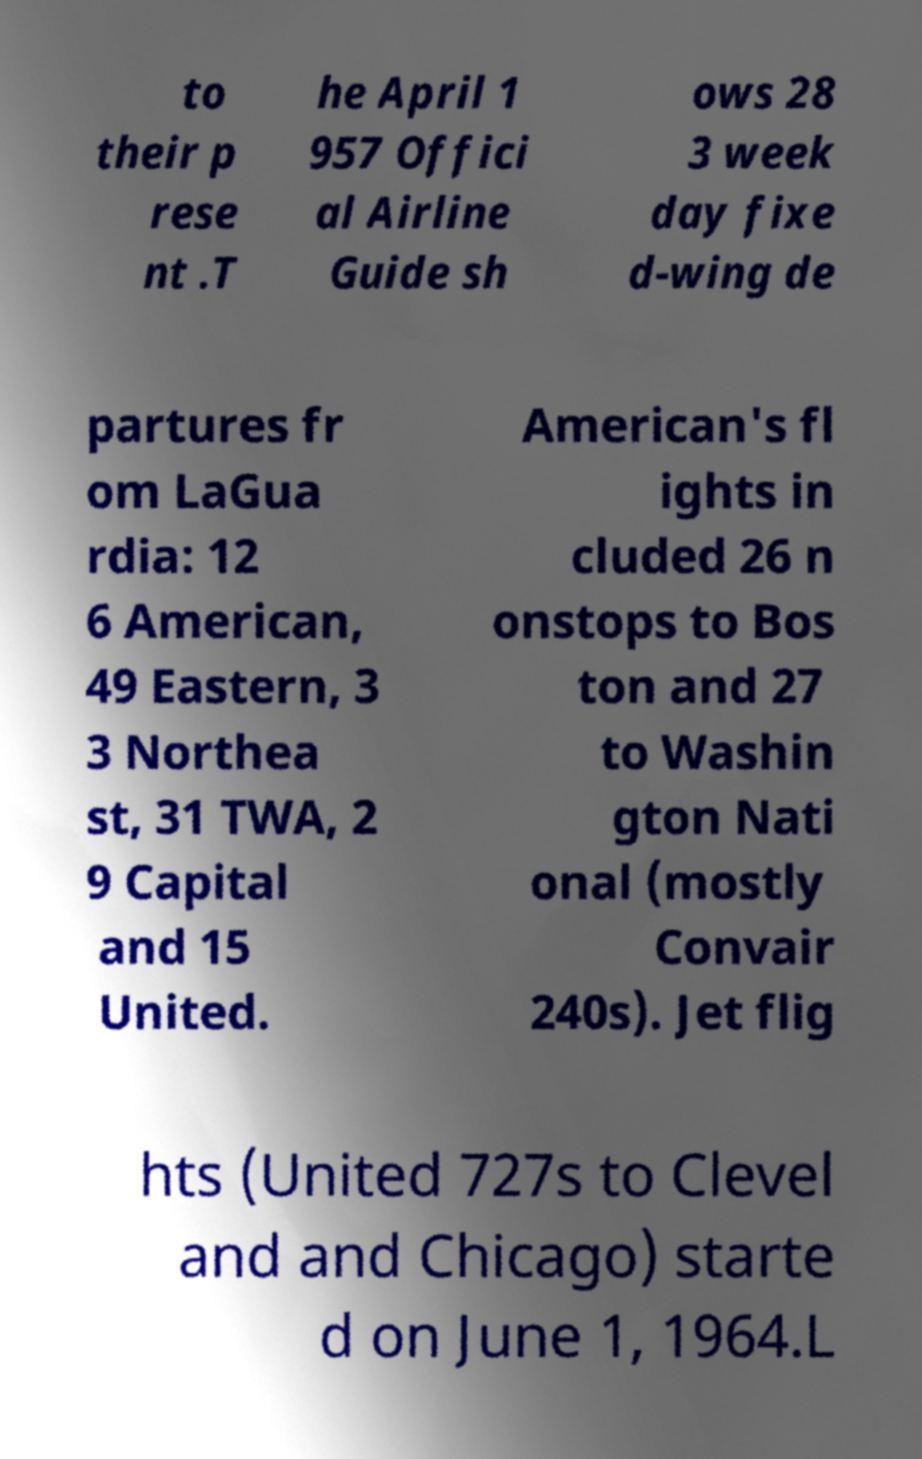Please read and relay the text visible in this image. What does it say? to their p rese nt .T he April 1 957 Offici al Airline Guide sh ows 28 3 week day fixe d-wing de partures fr om LaGua rdia: 12 6 American, 49 Eastern, 3 3 Northea st, 31 TWA, 2 9 Capital and 15 United. American's fl ights in cluded 26 n onstops to Bos ton and 27 to Washin gton Nati onal (mostly Convair 240s). Jet flig hts (United 727s to Clevel and and Chicago) starte d on June 1, 1964.L 